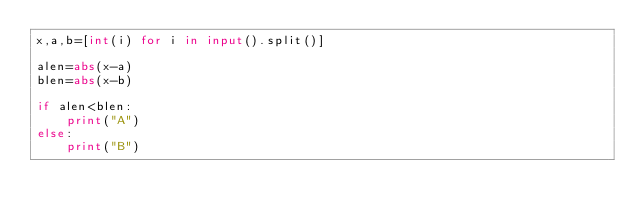<code> <loc_0><loc_0><loc_500><loc_500><_Python_>x,a,b=[int(i) for i in input().split()]

alen=abs(x-a)
blen=abs(x-b)

if alen<blen:
    print("A")
else:
    print("B")</code> 